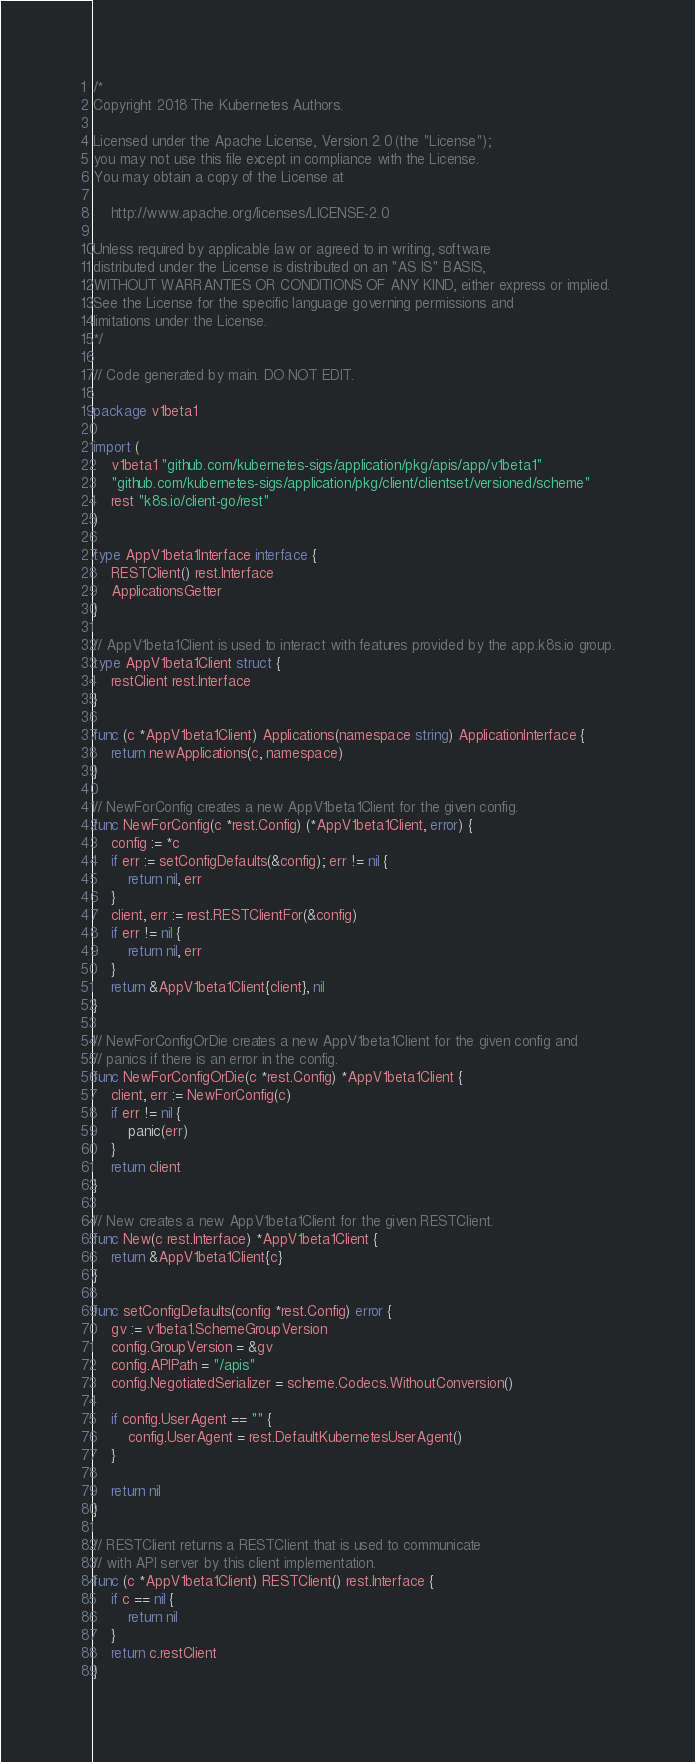<code> <loc_0><loc_0><loc_500><loc_500><_Go_>/*
Copyright 2018 The Kubernetes Authors.

Licensed under the Apache License, Version 2.0 (the "License");
you may not use this file except in compliance with the License.
You may obtain a copy of the License at

    http://www.apache.org/licenses/LICENSE-2.0

Unless required by applicable law or agreed to in writing, software
distributed under the License is distributed on an "AS IS" BASIS,
WITHOUT WARRANTIES OR CONDITIONS OF ANY KIND, either express or implied.
See the License for the specific language governing permissions and
limitations under the License.
*/

// Code generated by main. DO NOT EDIT.

package v1beta1

import (
	v1beta1 "github.com/kubernetes-sigs/application/pkg/apis/app/v1beta1"
	"github.com/kubernetes-sigs/application/pkg/client/clientset/versioned/scheme"
	rest "k8s.io/client-go/rest"
)

type AppV1beta1Interface interface {
	RESTClient() rest.Interface
	ApplicationsGetter
}

// AppV1beta1Client is used to interact with features provided by the app.k8s.io group.
type AppV1beta1Client struct {
	restClient rest.Interface
}

func (c *AppV1beta1Client) Applications(namespace string) ApplicationInterface {
	return newApplications(c, namespace)
}

// NewForConfig creates a new AppV1beta1Client for the given config.
func NewForConfig(c *rest.Config) (*AppV1beta1Client, error) {
	config := *c
	if err := setConfigDefaults(&config); err != nil {
		return nil, err
	}
	client, err := rest.RESTClientFor(&config)
	if err != nil {
		return nil, err
	}
	return &AppV1beta1Client{client}, nil
}

// NewForConfigOrDie creates a new AppV1beta1Client for the given config and
// panics if there is an error in the config.
func NewForConfigOrDie(c *rest.Config) *AppV1beta1Client {
	client, err := NewForConfig(c)
	if err != nil {
		panic(err)
	}
	return client
}

// New creates a new AppV1beta1Client for the given RESTClient.
func New(c rest.Interface) *AppV1beta1Client {
	return &AppV1beta1Client{c}
}

func setConfigDefaults(config *rest.Config) error {
	gv := v1beta1.SchemeGroupVersion
	config.GroupVersion = &gv
	config.APIPath = "/apis"
	config.NegotiatedSerializer = scheme.Codecs.WithoutConversion()

	if config.UserAgent == "" {
		config.UserAgent = rest.DefaultKubernetesUserAgent()
	}

	return nil
}

// RESTClient returns a RESTClient that is used to communicate
// with API server by this client implementation.
func (c *AppV1beta1Client) RESTClient() rest.Interface {
	if c == nil {
		return nil
	}
	return c.restClient
}
</code> 